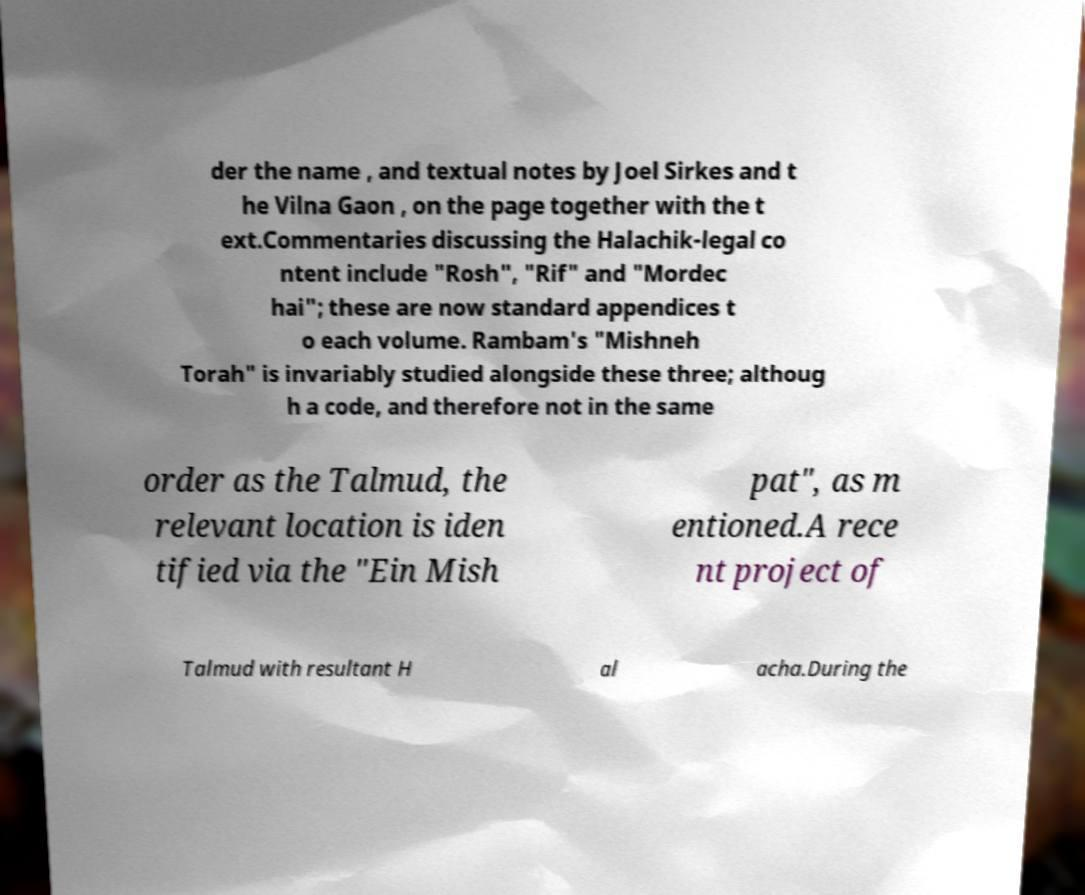I need the written content from this picture converted into text. Can you do that? der the name , and textual notes by Joel Sirkes and t he Vilna Gaon , on the page together with the t ext.Commentaries discussing the Halachik-legal co ntent include "Rosh", "Rif" and "Mordec hai"; these are now standard appendices t o each volume. Rambam's "Mishneh Torah" is invariably studied alongside these three; althoug h a code, and therefore not in the same order as the Talmud, the relevant location is iden tified via the "Ein Mish pat", as m entioned.A rece nt project of Talmud with resultant H al acha.During the 